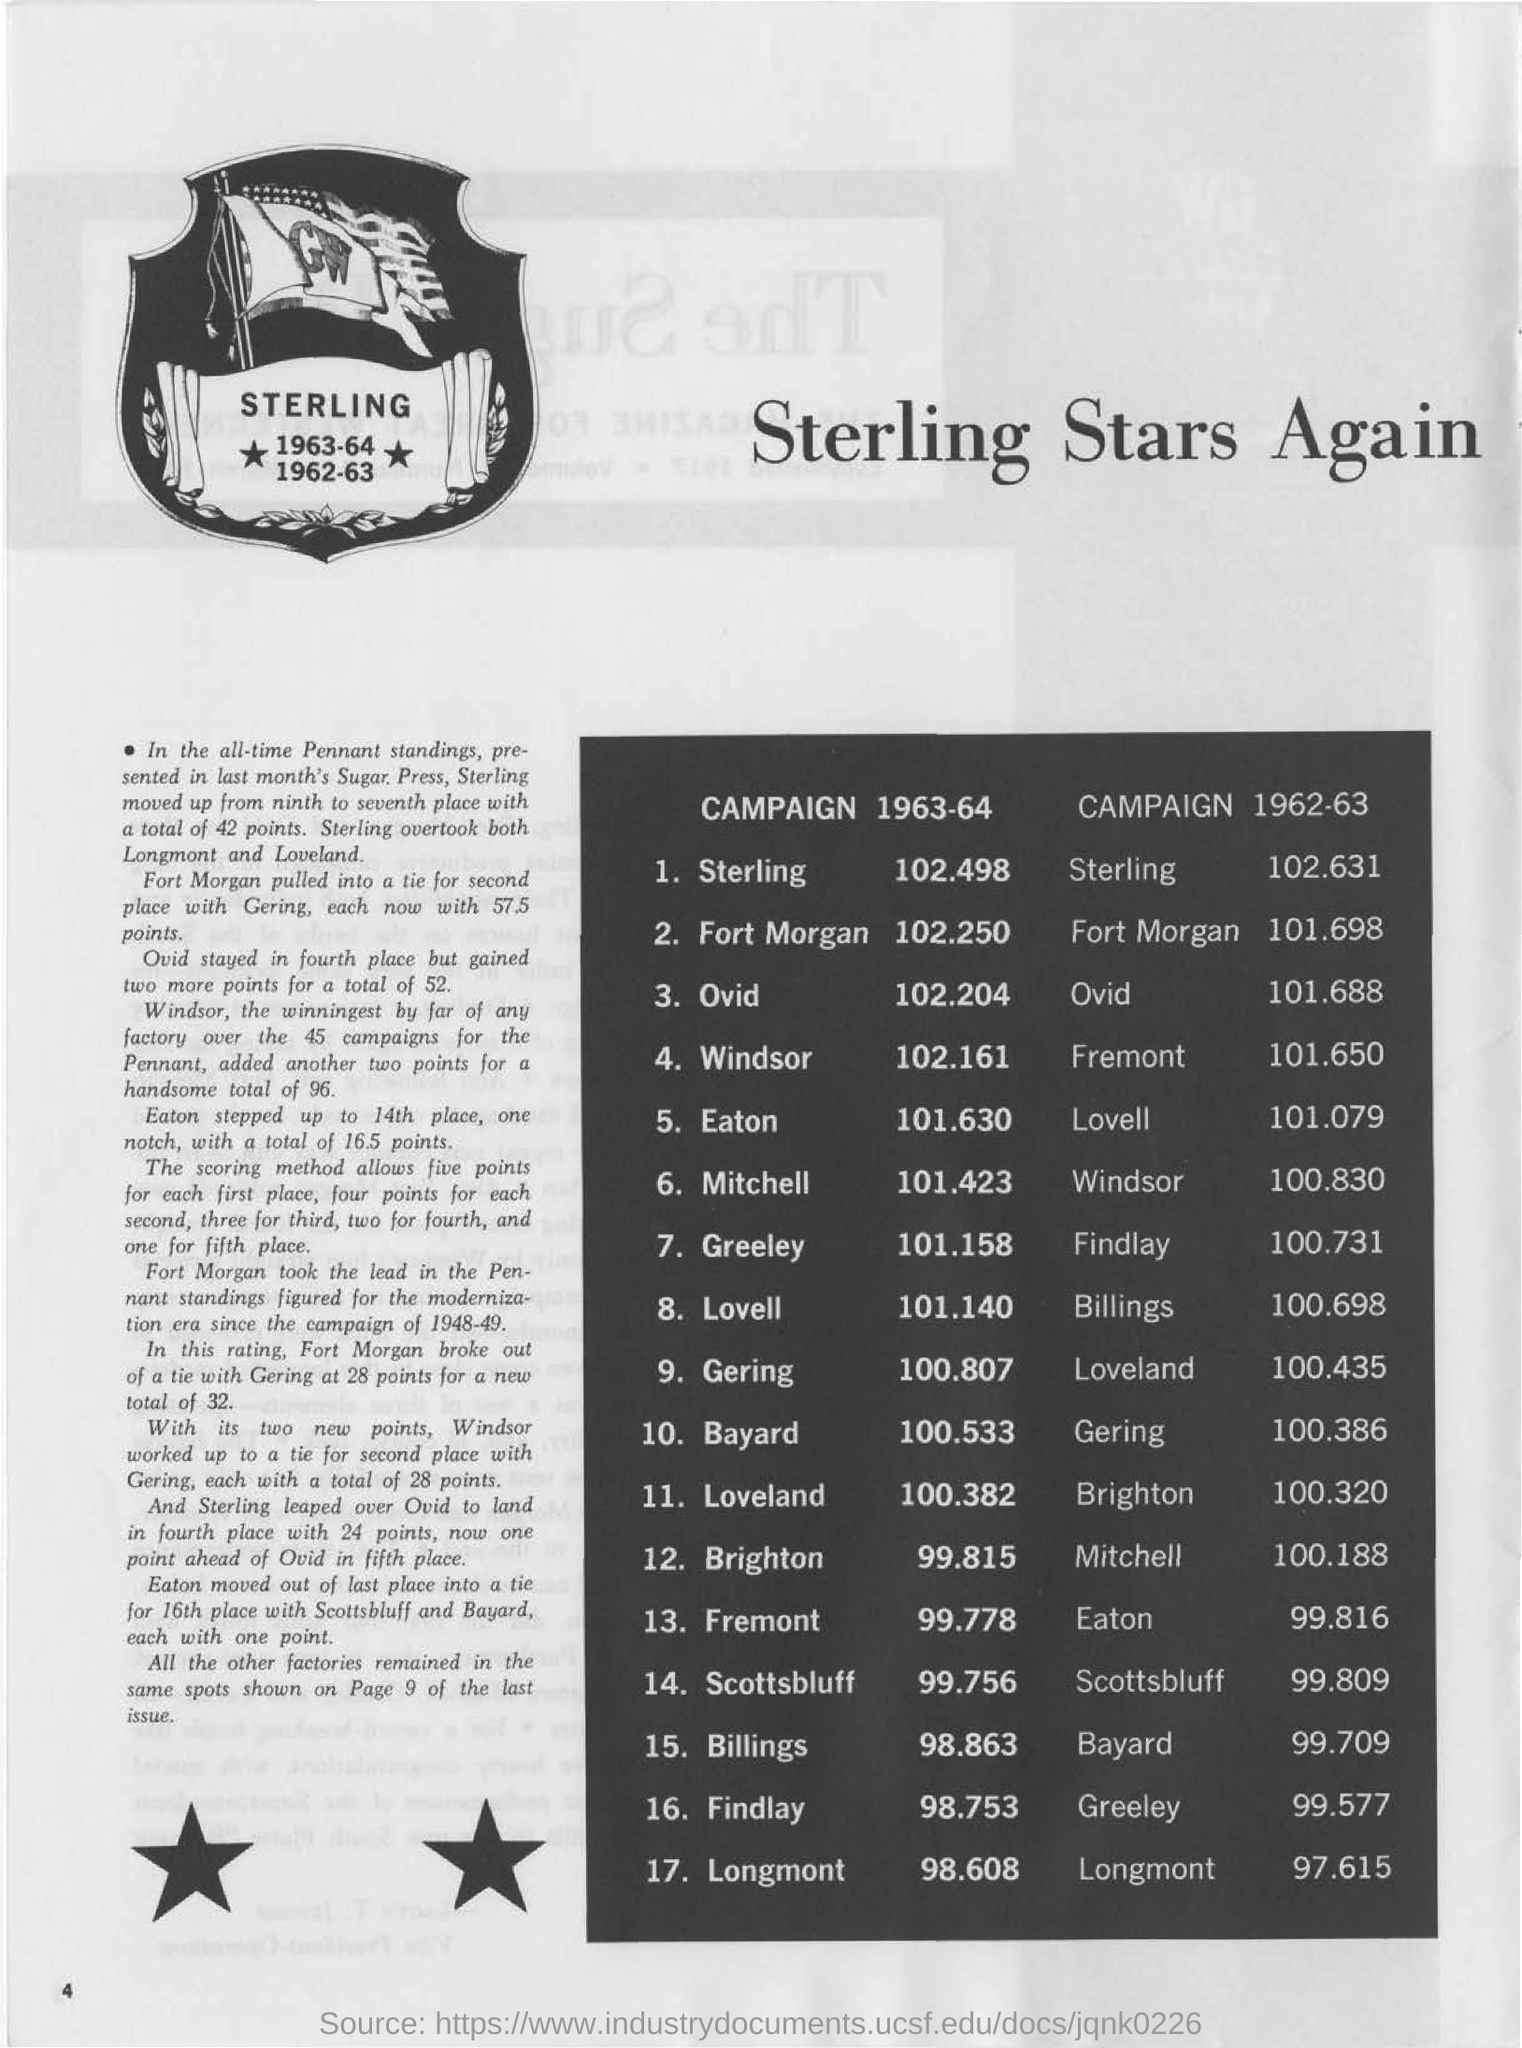Specify some key components in this picture. In the campaign of 1963-1964, Fort Morgan had a total point score of 102.250. In the 1962-63 campaign, Mitchell had a total of 100.188 points. During the 1962-63 campaign, Sterling had a total of 102.631 points. In the campaign of 1963-64, Windsor had a total of 102.161 points. 